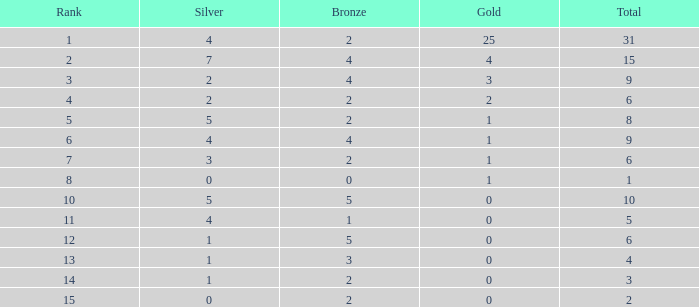What is the highest rank of the medal total less than 15, more than 2 bronzes, 0 gold and 1 silver? 13.0. 